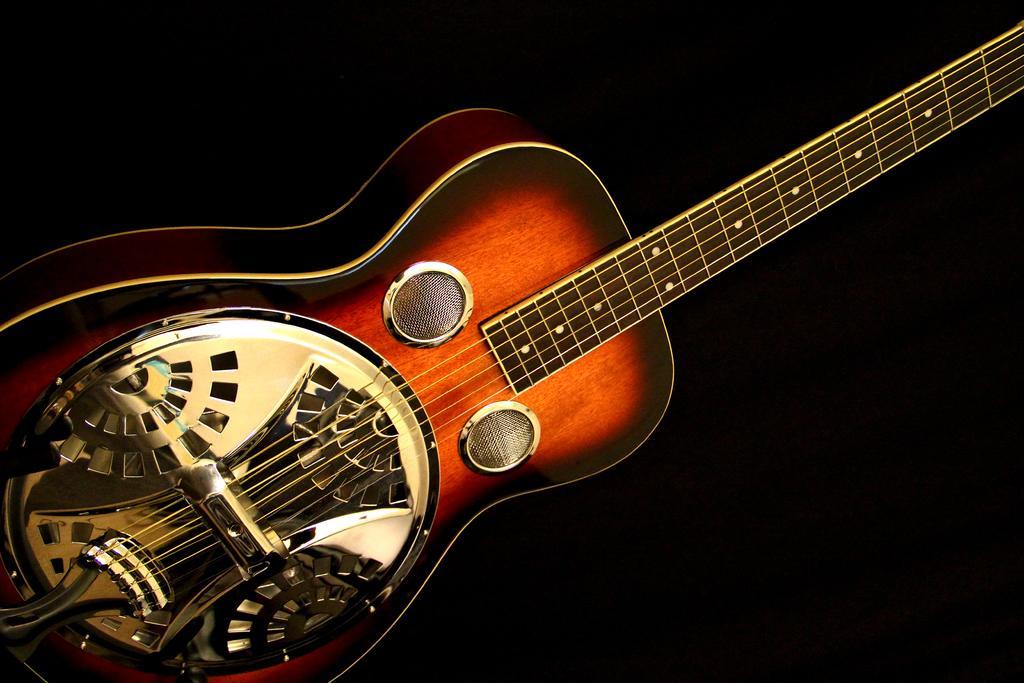Please provide a concise description of this image. In this image i can see a golden brown guitar and a dark background. 